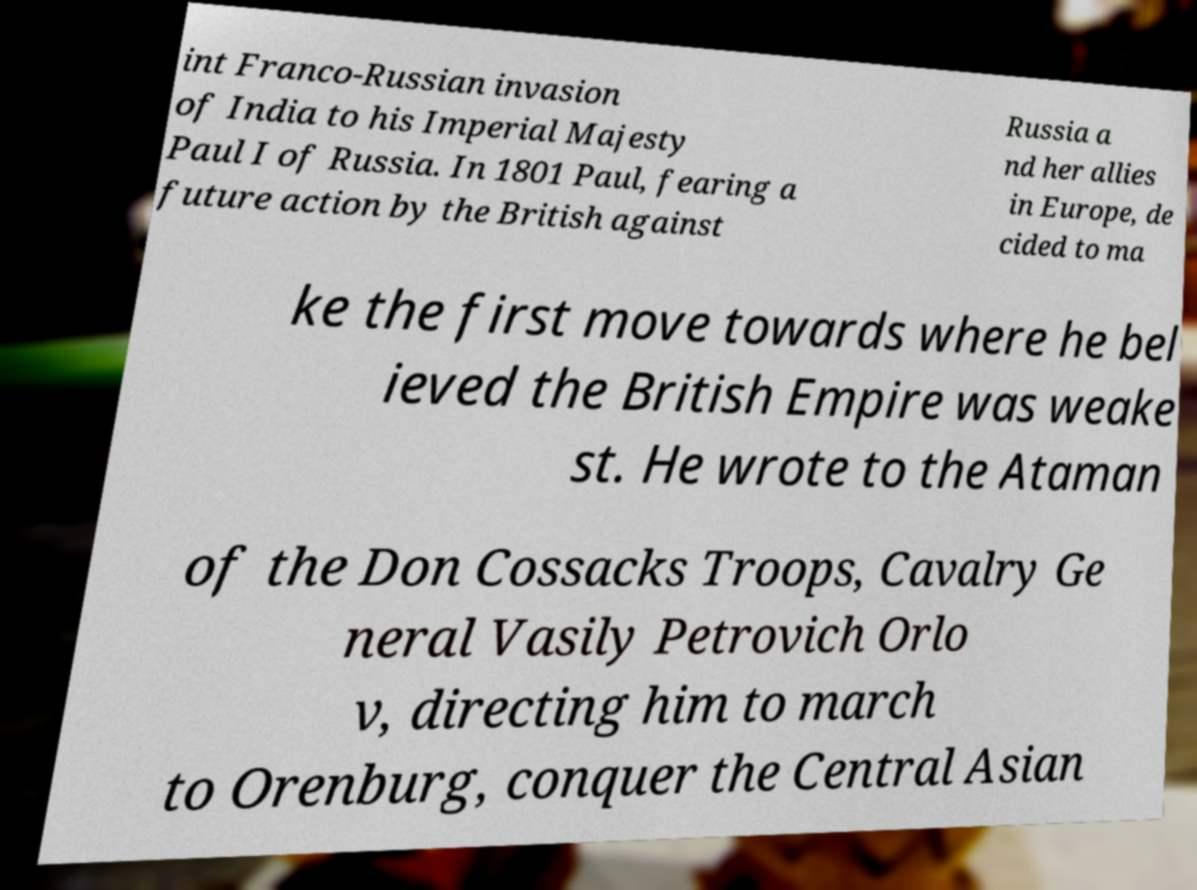I need the written content from this picture converted into text. Can you do that? int Franco-Russian invasion of India to his Imperial Majesty Paul I of Russia. In 1801 Paul, fearing a future action by the British against Russia a nd her allies in Europe, de cided to ma ke the first move towards where he bel ieved the British Empire was weake st. He wrote to the Ataman of the Don Cossacks Troops, Cavalry Ge neral Vasily Petrovich Orlo v, directing him to march to Orenburg, conquer the Central Asian 